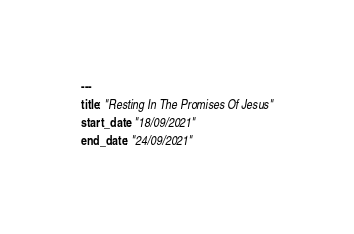Convert code to text. <code><loc_0><loc_0><loc_500><loc_500><_YAML_>---
title: "Resting In The Promises Of Jesus"
start_date: "18/09/2021"
end_date: "24/09/2021"</code> 